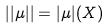<formula> <loc_0><loc_0><loc_500><loc_500>| | \mu | | = | \mu | ( X )</formula> 